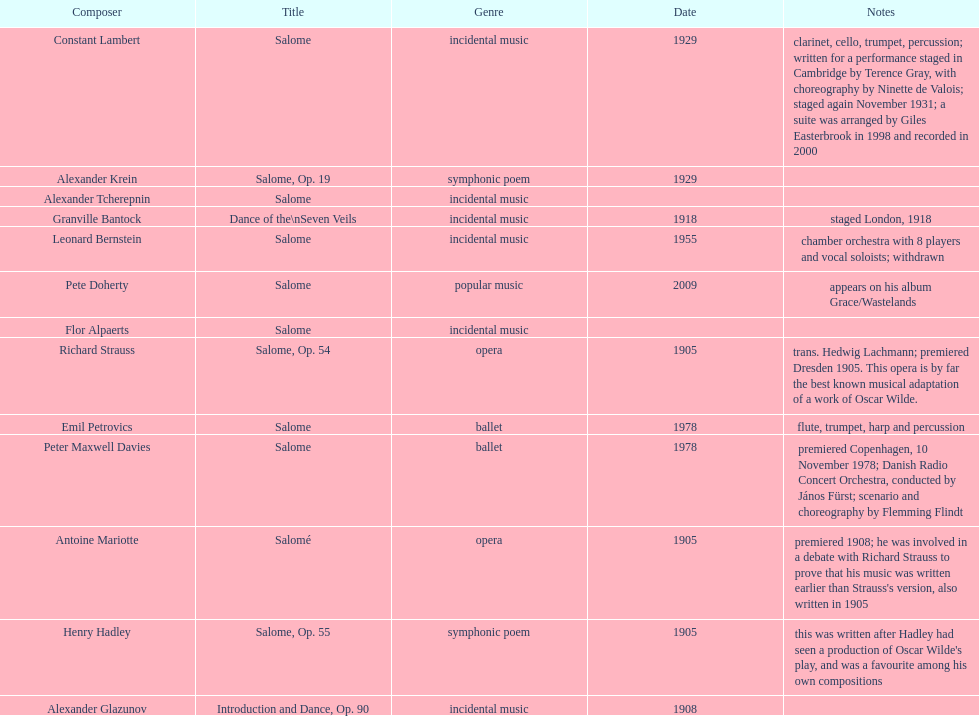After witnessing an oscar wilde play, what did henry hadley write? Salome, Op. 55. 